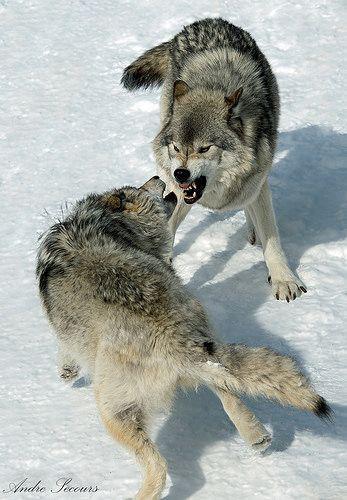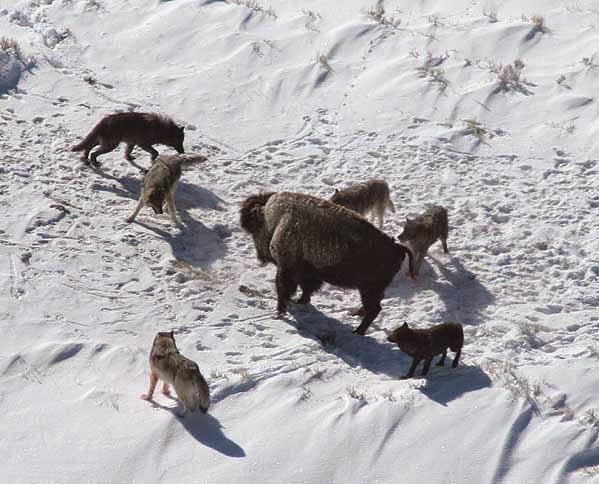The first image is the image on the left, the second image is the image on the right. For the images shown, is this caption "There are no more than two wolves." true? Answer yes or no. No. The first image is the image on the left, the second image is the image on the right. Considering the images on both sides, is "A non-canine mammal can be seen in one or more of the images." valid? Answer yes or no. Yes. 